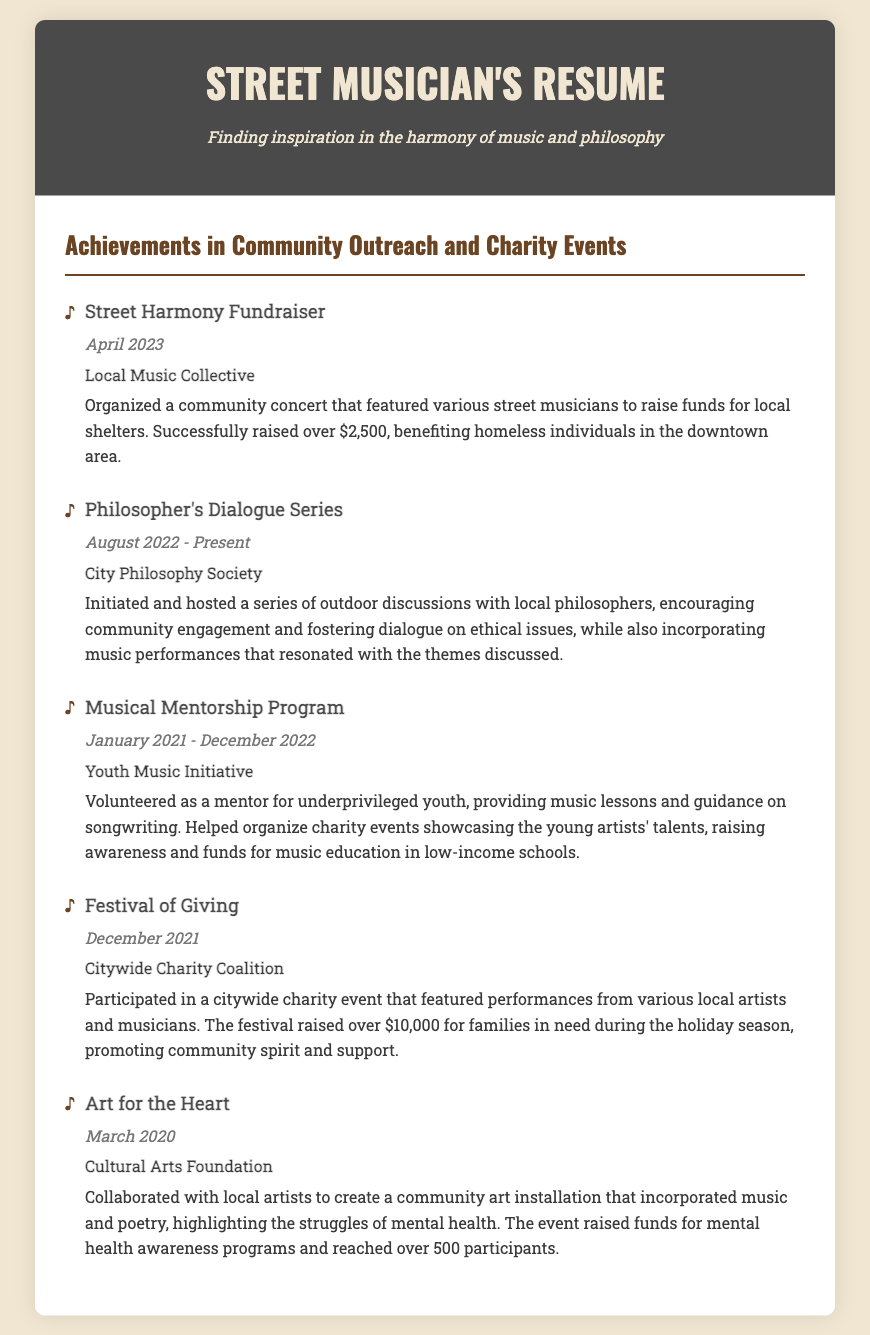what is the name of the first achievement? The first achievement listed in the document is the Street Harmony Fundraiser.
Answer: Street Harmony Fundraiser how much money was raised in the Street Harmony Fundraiser? The document states that over $2,500 was raised in the Street Harmony Fundraiser.
Answer: over $2,500 which organization initiated the Philosopher's Dialogue Series? The organization that initiated the Philosopher's Dialogue Series is the City Philosophy Society.
Answer: City Philosophy Society what was the date range for the Musical Mentorship Program? The date range for the Musical Mentorship Program is January 2021 to December 2022.
Answer: January 2021 - December 2022 how many participants did the Art for the Heart event reach? The Art for the Heart event reached over 500 participants.
Answer: over 500 what is the total amount raised during the Festival of Giving? The total amount raised during the Festival of Giving is over $10,000.
Answer: over $10,000 which achievement focuses on mental health awareness? The achievement that focuses on mental health awareness is Art for the Heart.
Answer: Art for the Heart what type of event was the Festival of Giving? The Festival of Giving was a citywide charity event.
Answer: citywide charity event who did the Musical Mentorship Program provide guidance to? The Musical Mentorship Program provided guidance to underprivileged youth.
Answer: underprivileged youth 